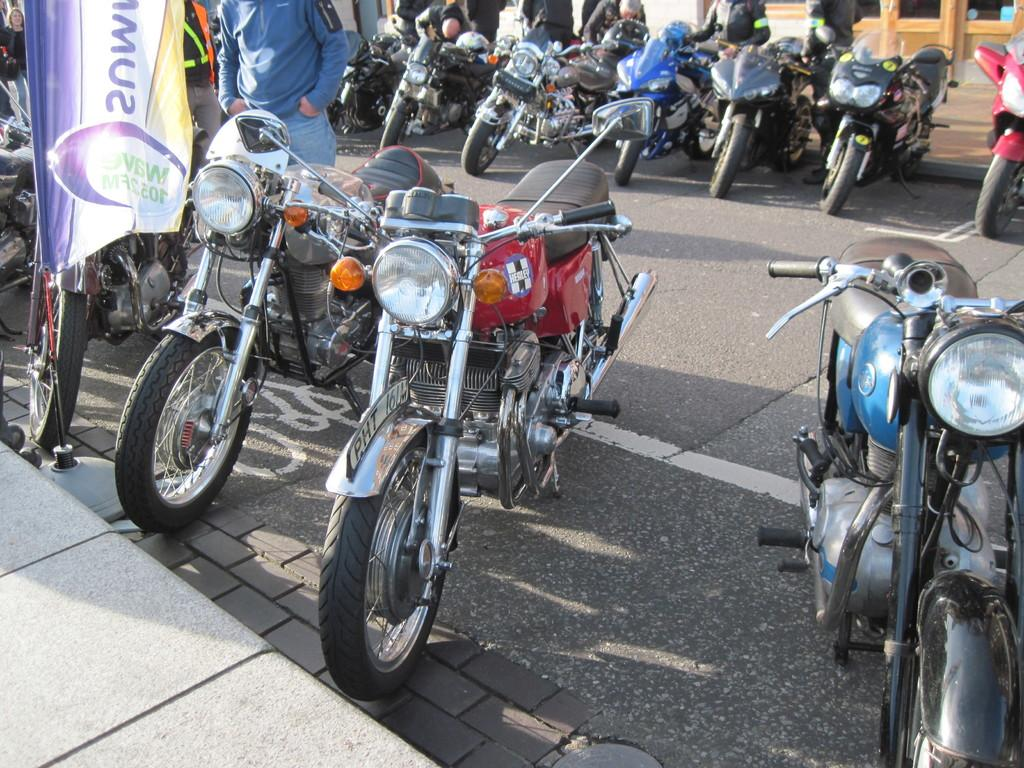What is located in the center of the image? There are bikes and people in the center of the image. What is the setting where the bikes and people are situated? The bikes and people are on the road. What is visible at the bottom of the image? There is a footpath at the bottom of the image. Can you tell me how many snails are crawling on the bikes in the image? There are no snails visible on the bikes in the image. What type of honey is being used by the people in the image? There is no reference to honey in the image. 